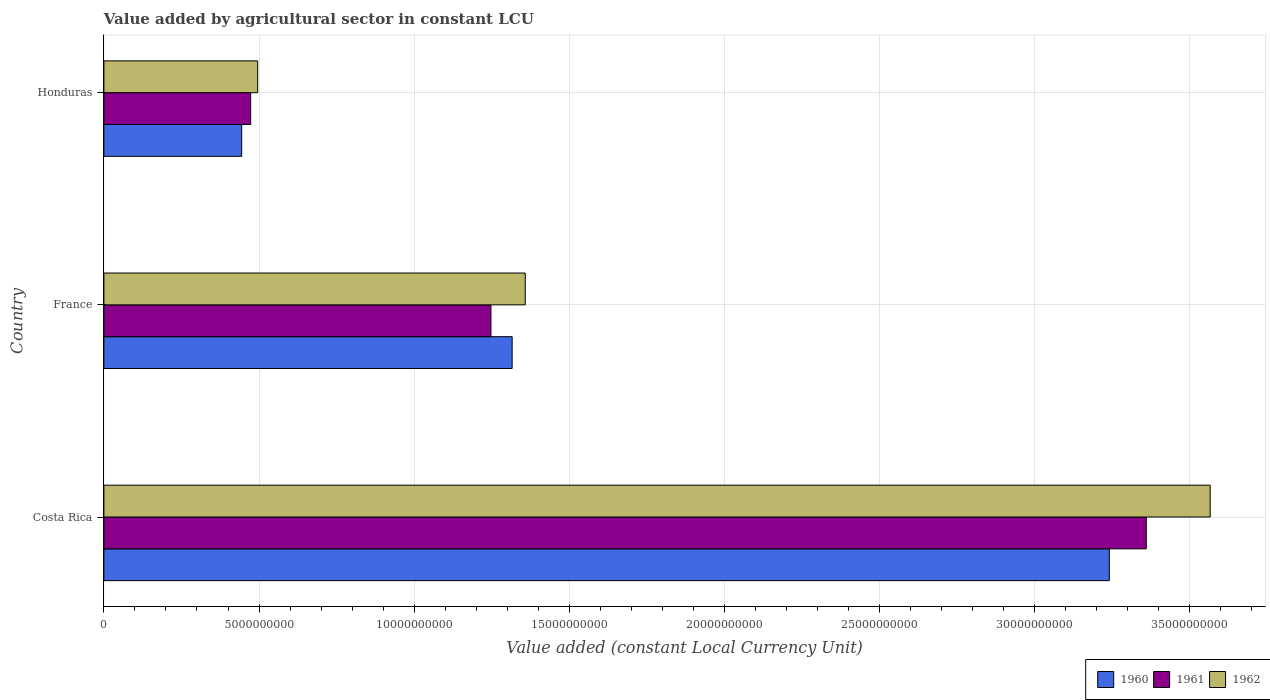Are the number of bars per tick equal to the number of legend labels?
Offer a very short reply. Yes. How many bars are there on the 3rd tick from the top?
Your answer should be compact. 3. How many bars are there on the 1st tick from the bottom?
Give a very brief answer. 3. What is the label of the 3rd group of bars from the top?
Provide a short and direct response. Costa Rica. What is the value added by agricultural sector in 1960 in France?
Keep it short and to the point. 1.32e+1. Across all countries, what is the maximum value added by agricultural sector in 1961?
Offer a very short reply. 3.36e+1. Across all countries, what is the minimum value added by agricultural sector in 1960?
Provide a short and direct response. 4.44e+09. In which country was the value added by agricultural sector in 1960 maximum?
Make the answer very short. Costa Rica. In which country was the value added by agricultural sector in 1960 minimum?
Offer a very short reply. Honduras. What is the total value added by agricultural sector in 1962 in the graph?
Offer a very short reply. 5.42e+1. What is the difference between the value added by agricultural sector in 1961 in Costa Rica and that in Honduras?
Ensure brevity in your answer.  2.89e+1. What is the difference between the value added by agricultural sector in 1961 in Honduras and the value added by agricultural sector in 1960 in France?
Offer a terse response. -8.43e+09. What is the average value added by agricultural sector in 1960 per country?
Make the answer very short. 1.67e+1. What is the difference between the value added by agricultural sector in 1960 and value added by agricultural sector in 1961 in Honduras?
Your response must be concise. -2.90e+08. What is the ratio of the value added by agricultural sector in 1961 in France to that in Honduras?
Keep it short and to the point. 2.64. What is the difference between the highest and the second highest value added by agricultural sector in 1960?
Provide a succinct answer. 1.92e+1. What is the difference between the highest and the lowest value added by agricultural sector in 1962?
Your response must be concise. 3.07e+1. Is it the case that in every country, the sum of the value added by agricultural sector in 1961 and value added by agricultural sector in 1962 is greater than the value added by agricultural sector in 1960?
Your answer should be compact. Yes. What is the difference between two consecutive major ticks on the X-axis?
Provide a short and direct response. 5.00e+09. Does the graph contain any zero values?
Offer a terse response. No. Does the graph contain grids?
Your answer should be very brief. Yes. What is the title of the graph?
Provide a succinct answer. Value added by agricultural sector in constant LCU. Does "2002" appear as one of the legend labels in the graph?
Keep it short and to the point. No. What is the label or title of the X-axis?
Your response must be concise. Value added (constant Local Currency Unit). What is the Value added (constant Local Currency Unit) of 1960 in Costa Rica?
Make the answer very short. 3.24e+1. What is the Value added (constant Local Currency Unit) in 1961 in Costa Rica?
Ensure brevity in your answer.  3.36e+1. What is the Value added (constant Local Currency Unit) of 1962 in Costa Rica?
Offer a terse response. 3.57e+1. What is the Value added (constant Local Currency Unit) in 1960 in France?
Offer a terse response. 1.32e+1. What is the Value added (constant Local Currency Unit) in 1961 in France?
Your answer should be very brief. 1.25e+1. What is the Value added (constant Local Currency Unit) of 1962 in France?
Make the answer very short. 1.36e+1. What is the Value added (constant Local Currency Unit) in 1960 in Honduras?
Ensure brevity in your answer.  4.44e+09. What is the Value added (constant Local Currency Unit) of 1961 in Honduras?
Your response must be concise. 4.73e+09. What is the Value added (constant Local Currency Unit) of 1962 in Honduras?
Give a very brief answer. 4.96e+09. Across all countries, what is the maximum Value added (constant Local Currency Unit) in 1960?
Make the answer very short. 3.24e+1. Across all countries, what is the maximum Value added (constant Local Currency Unit) in 1961?
Provide a short and direct response. 3.36e+1. Across all countries, what is the maximum Value added (constant Local Currency Unit) of 1962?
Provide a succinct answer. 3.57e+1. Across all countries, what is the minimum Value added (constant Local Currency Unit) in 1960?
Provide a succinct answer. 4.44e+09. Across all countries, what is the minimum Value added (constant Local Currency Unit) in 1961?
Offer a terse response. 4.73e+09. Across all countries, what is the minimum Value added (constant Local Currency Unit) of 1962?
Offer a terse response. 4.96e+09. What is the total Value added (constant Local Currency Unit) of 1960 in the graph?
Offer a very short reply. 5.00e+1. What is the total Value added (constant Local Currency Unit) of 1961 in the graph?
Offer a terse response. 5.08e+1. What is the total Value added (constant Local Currency Unit) in 1962 in the graph?
Give a very brief answer. 5.42e+1. What is the difference between the Value added (constant Local Currency Unit) in 1960 in Costa Rica and that in France?
Give a very brief answer. 1.92e+1. What is the difference between the Value added (constant Local Currency Unit) in 1961 in Costa Rica and that in France?
Keep it short and to the point. 2.11e+1. What is the difference between the Value added (constant Local Currency Unit) of 1962 in Costa Rica and that in France?
Make the answer very short. 2.21e+1. What is the difference between the Value added (constant Local Currency Unit) of 1960 in Costa Rica and that in Honduras?
Offer a terse response. 2.80e+1. What is the difference between the Value added (constant Local Currency Unit) of 1961 in Costa Rica and that in Honduras?
Give a very brief answer. 2.89e+1. What is the difference between the Value added (constant Local Currency Unit) of 1962 in Costa Rica and that in Honduras?
Offer a very short reply. 3.07e+1. What is the difference between the Value added (constant Local Currency Unit) of 1960 in France and that in Honduras?
Keep it short and to the point. 8.72e+09. What is the difference between the Value added (constant Local Currency Unit) in 1961 in France and that in Honduras?
Offer a terse response. 7.74e+09. What is the difference between the Value added (constant Local Currency Unit) in 1962 in France and that in Honduras?
Make the answer very short. 8.63e+09. What is the difference between the Value added (constant Local Currency Unit) of 1960 in Costa Rica and the Value added (constant Local Currency Unit) of 1961 in France?
Your answer should be very brief. 1.99e+1. What is the difference between the Value added (constant Local Currency Unit) of 1960 in Costa Rica and the Value added (constant Local Currency Unit) of 1962 in France?
Keep it short and to the point. 1.88e+1. What is the difference between the Value added (constant Local Currency Unit) of 1961 in Costa Rica and the Value added (constant Local Currency Unit) of 1962 in France?
Provide a succinct answer. 2.00e+1. What is the difference between the Value added (constant Local Currency Unit) in 1960 in Costa Rica and the Value added (constant Local Currency Unit) in 1961 in Honduras?
Keep it short and to the point. 2.77e+1. What is the difference between the Value added (constant Local Currency Unit) of 1960 in Costa Rica and the Value added (constant Local Currency Unit) of 1962 in Honduras?
Your response must be concise. 2.74e+1. What is the difference between the Value added (constant Local Currency Unit) of 1961 in Costa Rica and the Value added (constant Local Currency Unit) of 1962 in Honduras?
Give a very brief answer. 2.86e+1. What is the difference between the Value added (constant Local Currency Unit) in 1960 in France and the Value added (constant Local Currency Unit) in 1961 in Honduras?
Give a very brief answer. 8.43e+09. What is the difference between the Value added (constant Local Currency Unit) of 1960 in France and the Value added (constant Local Currency Unit) of 1962 in Honduras?
Provide a succinct answer. 8.20e+09. What is the difference between the Value added (constant Local Currency Unit) in 1961 in France and the Value added (constant Local Currency Unit) in 1962 in Honduras?
Make the answer very short. 7.52e+09. What is the average Value added (constant Local Currency Unit) in 1960 per country?
Your answer should be very brief. 1.67e+1. What is the average Value added (constant Local Currency Unit) of 1961 per country?
Provide a succinct answer. 1.69e+1. What is the average Value added (constant Local Currency Unit) of 1962 per country?
Ensure brevity in your answer.  1.81e+1. What is the difference between the Value added (constant Local Currency Unit) in 1960 and Value added (constant Local Currency Unit) in 1961 in Costa Rica?
Your response must be concise. -1.19e+09. What is the difference between the Value added (constant Local Currency Unit) of 1960 and Value added (constant Local Currency Unit) of 1962 in Costa Rica?
Offer a terse response. -3.25e+09. What is the difference between the Value added (constant Local Currency Unit) in 1961 and Value added (constant Local Currency Unit) in 1962 in Costa Rica?
Your answer should be compact. -2.06e+09. What is the difference between the Value added (constant Local Currency Unit) of 1960 and Value added (constant Local Currency Unit) of 1961 in France?
Your response must be concise. 6.84e+08. What is the difference between the Value added (constant Local Currency Unit) of 1960 and Value added (constant Local Currency Unit) of 1962 in France?
Ensure brevity in your answer.  -4.23e+08. What is the difference between the Value added (constant Local Currency Unit) of 1961 and Value added (constant Local Currency Unit) of 1962 in France?
Make the answer very short. -1.11e+09. What is the difference between the Value added (constant Local Currency Unit) in 1960 and Value added (constant Local Currency Unit) in 1961 in Honduras?
Your response must be concise. -2.90e+08. What is the difference between the Value added (constant Local Currency Unit) in 1960 and Value added (constant Local Currency Unit) in 1962 in Honduras?
Provide a succinct answer. -5.15e+08. What is the difference between the Value added (constant Local Currency Unit) of 1961 and Value added (constant Local Currency Unit) of 1962 in Honduras?
Your answer should be compact. -2.25e+08. What is the ratio of the Value added (constant Local Currency Unit) of 1960 in Costa Rica to that in France?
Provide a succinct answer. 2.46. What is the ratio of the Value added (constant Local Currency Unit) of 1961 in Costa Rica to that in France?
Your response must be concise. 2.69. What is the ratio of the Value added (constant Local Currency Unit) of 1962 in Costa Rica to that in France?
Your answer should be compact. 2.63. What is the ratio of the Value added (constant Local Currency Unit) of 1960 in Costa Rica to that in Honduras?
Offer a very short reply. 7.3. What is the ratio of the Value added (constant Local Currency Unit) of 1961 in Costa Rica to that in Honduras?
Give a very brief answer. 7.1. What is the ratio of the Value added (constant Local Currency Unit) in 1962 in Costa Rica to that in Honduras?
Give a very brief answer. 7.2. What is the ratio of the Value added (constant Local Currency Unit) in 1960 in France to that in Honduras?
Offer a terse response. 2.96. What is the ratio of the Value added (constant Local Currency Unit) in 1961 in France to that in Honduras?
Ensure brevity in your answer.  2.64. What is the ratio of the Value added (constant Local Currency Unit) of 1962 in France to that in Honduras?
Your response must be concise. 2.74. What is the difference between the highest and the second highest Value added (constant Local Currency Unit) of 1960?
Ensure brevity in your answer.  1.92e+1. What is the difference between the highest and the second highest Value added (constant Local Currency Unit) of 1961?
Offer a terse response. 2.11e+1. What is the difference between the highest and the second highest Value added (constant Local Currency Unit) of 1962?
Provide a succinct answer. 2.21e+1. What is the difference between the highest and the lowest Value added (constant Local Currency Unit) in 1960?
Your answer should be compact. 2.80e+1. What is the difference between the highest and the lowest Value added (constant Local Currency Unit) of 1961?
Ensure brevity in your answer.  2.89e+1. What is the difference between the highest and the lowest Value added (constant Local Currency Unit) in 1962?
Your answer should be very brief. 3.07e+1. 